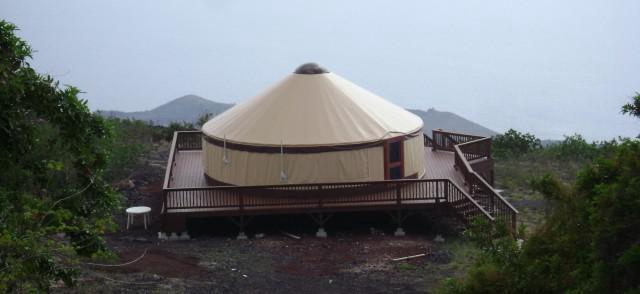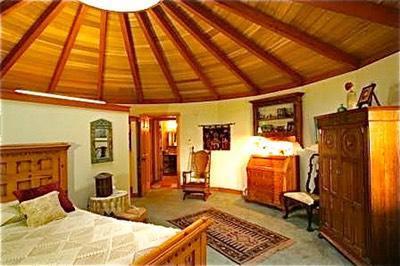The first image is the image on the left, the second image is the image on the right. For the images shown, is this caption "A raised ramp surrounds the hut in the image on the left." true? Answer yes or no. Yes. The first image is the image on the left, the second image is the image on the right. Analyze the images presented: Is the assertion "All images show only the exteriors of homes." valid? Answer yes or no. No. The first image is the image on the left, the second image is the image on the right. Assess this claim about the two images: "In one image, a yurt with similar colored walls and ceiling with a dark rim where the roof connects, has a door, but no windows.". Correct or not? Answer yes or no. Yes. 